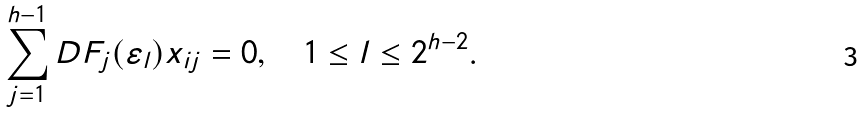Convert formula to latex. <formula><loc_0><loc_0><loc_500><loc_500>\sum _ { j = 1 } ^ { h - 1 } D F _ { j } ( \varepsilon _ { l } ) x _ { i j } = 0 , \quad 1 \leq l \leq 2 ^ { h - 2 } .</formula> 